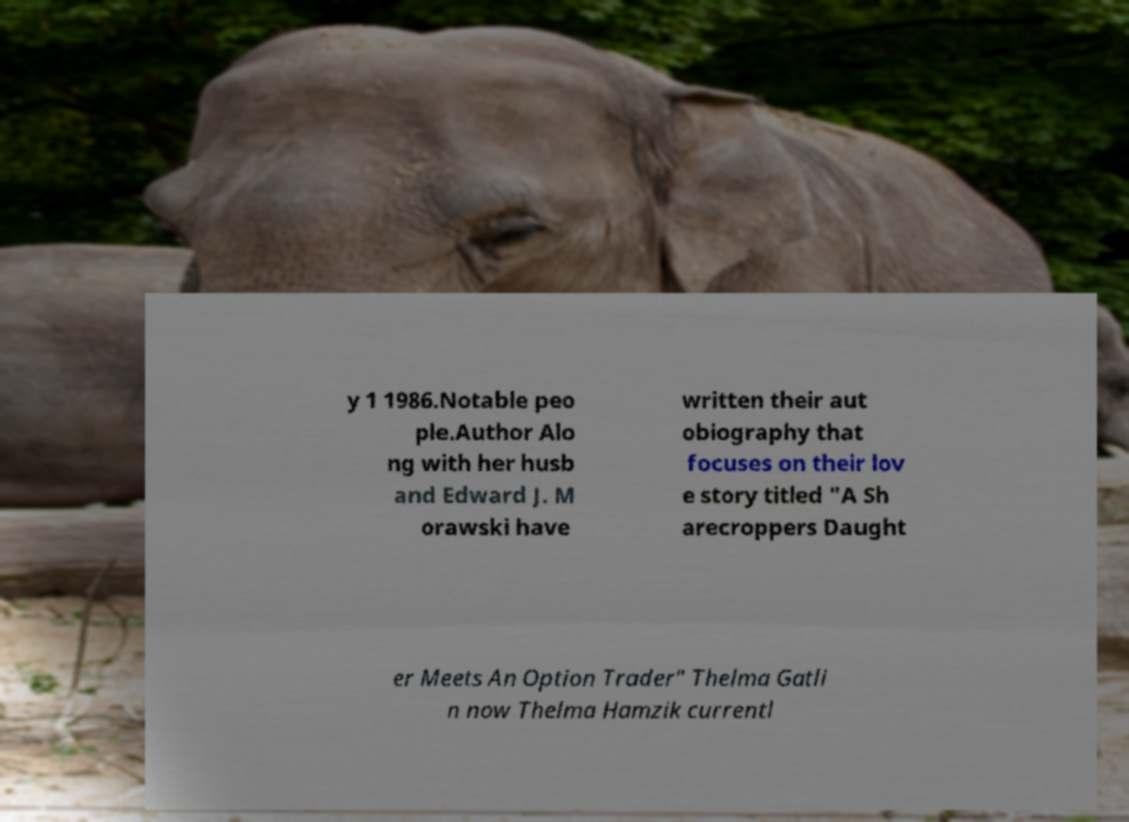Please read and relay the text visible in this image. What does it say? y 1 1986.Notable peo ple.Author Alo ng with her husb and Edward J. M orawski have written their aut obiography that focuses on their lov e story titled "A Sh arecroppers Daught er Meets An Option Trader" Thelma Gatli n now Thelma Hamzik currentl 